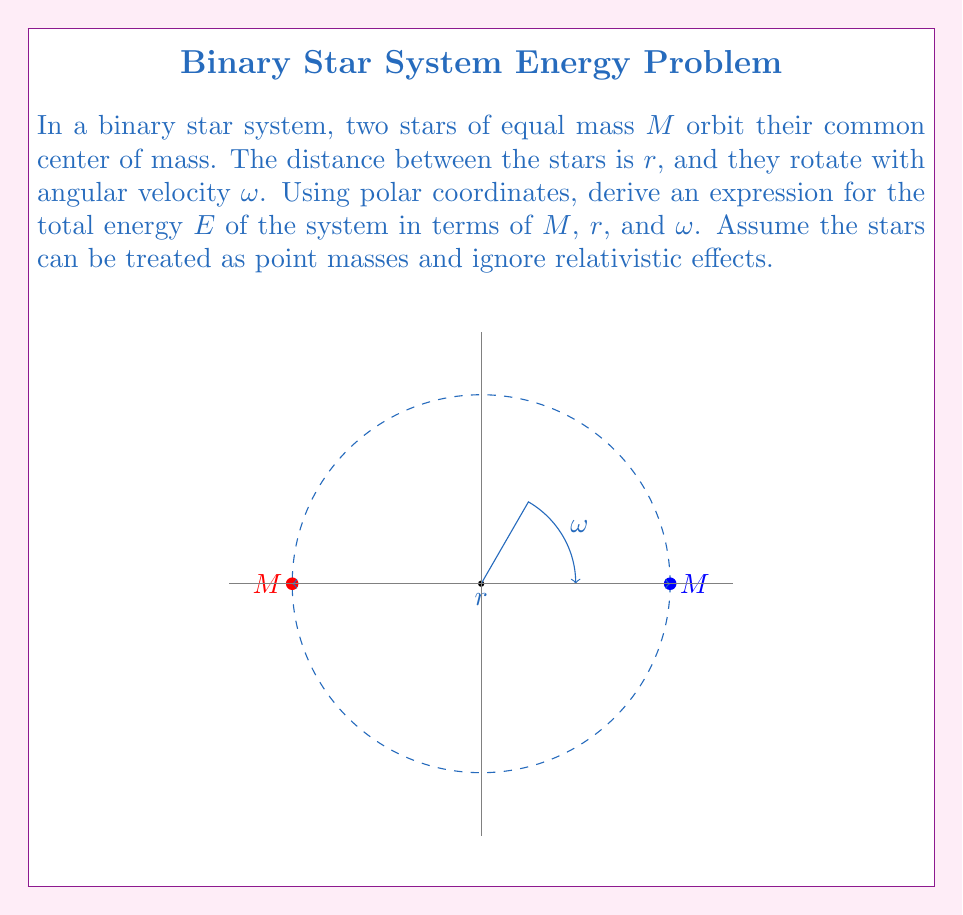What is the answer to this math problem? Let's approach this step-by-step:

1) The total energy $E$ of the system is the sum of kinetic energy $T$ and potential energy $V$:

   $$E = T + V$$

2) For the kinetic energy, we need to consider both stars. In polar coordinates, the velocity of each star is $r\omega/2$ (half the total separation times angular velocity). So the kinetic energy is:

   $$T = \frac{1}{2}M(\frac{r\omega}{2})^2 + \frac{1}{2}M(\frac{r\omega}{2})^2 = \frac{1}{4}Mr^2\omega^2$$

3) The potential energy is gravitational. The gravitational potential energy between two masses $M$ separated by distance $r$ is:

   $$V = -\frac{GM^2}{r}$$

   where $G$ is the gravitational constant.

4) Combining these, we get:

   $$E = \frac{1}{4}Mr^2\omega^2 - \frac{GM^2}{r}$$

5) This is our final expression for the total energy of the system in terms of $M$, $r$, and $\omega$.
Answer: $E = \frac{1}{4}Mr^2\omega^2 - \frac{GM^2}{r}$ 